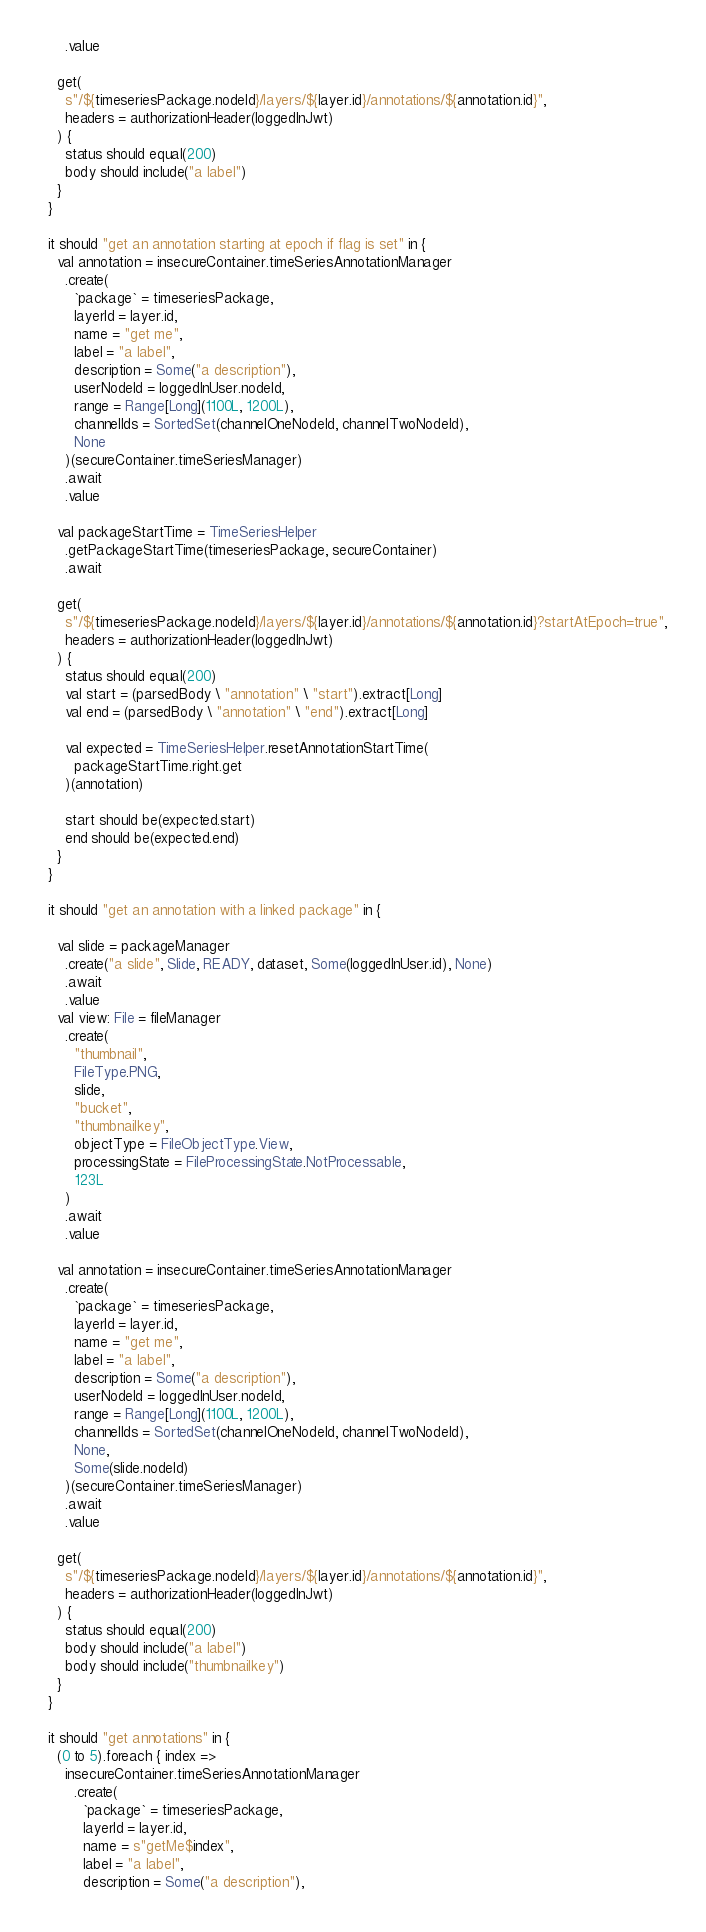Convert code to text. <code><loc_0><loc_0><loc_500><loc_500><_Scala_>      .value

    get(
      s"/${timeseriesPackage.nodeId}/layers/${layer.id}/annotations/${annotation.id}",
      headers = authorizationHeader(loggedInJwt)
    ) {
      status should equal(200)
      body should include("a label")
    }
  }

  it should "get an annotation starting at epoch if flag is set" in {
    val annotation = insecureContainer.timeSeriesAnnotationManager
      .create(
        `package` = timeseriesPackage,
        layerId = layer.id,
        name = "get me",
        label = "a label",
        description = Some("a description"),
        userNodeId = loggedInUser.nodeId,
        range = Range[Long](1100L, 1200L),
        channelIds = SortedSet(channelOneNodeId, channelTwoNodeId),
        None
      )(secureContainer.timeSeriesManager)
      .await
      .value

    val packageStartTime = TimeSeriesHelper
      .getPackageStartTime(timeseriesPackage, secureContainer)
      .await

    get(
      s"/${timeseriesPackage.nodeId}/layers/${layer.id}/annotations/${annotation.id}?startAtEpoch=true",
      headers = authorizationHeader(loggedInJwt)
    ) {
      status should equal(200)
      val start = (parsedBody \ "annotation" \ "start").extract[Long]
      val end = (parsedBody \ "annotation" \ "end").extract[Long]

      val expected = TimeSeriesHelper.resetAnnotationStartTime(
        packageStartTime.right.get
      )(annotation)

      start should be(expected.start)
      end should be(expected.end)
    }
  }

  it should "get an annotation with a linked package" in {

    val slide = packageManager
      .create("a slide", Slide, READY, dataset, Some(loggedInUser.id), None)
      .await
      .value
    val view: File = fileManager
      .create(
        "thumbnail",
        FileType.PNG,
        slide,
        "bucket",
        "thumbnailkey",
        objectType = FileObjectType.View,
        processingState = FileProcessingState.NotProcessable,
        123L
      )
      .await
      .value

    val annotation = insecureContainer.timeSeriesAnnotationManager
      .create(
        `package` = timeseriesPackage,
        layerId = layer.id,
        name = "get me",
        label = "a label",
        description = Some("a description"),
        userNodeId = loggedInUser.nodeId,
        range = Range[Long](1100L, 1200L),
        channelIds = SortedSet(channelOneNodeId, channelTwoNodeId),
        None,
        Some(slide.nodeId)
      )(secureContainer.timeSeriesManager)
      .await
      .value

    get(
      s"/${timeseriesPackage.nodeId}/layers/${layer.id}/annotations/${annotation.id}",
      headers = authorizationHeader(loggedInJwt)
    ) {
      status should equal(200)
      body should include("a label")
      body should include("thumbnailkey")
    }
  }

  it should "get annotations" in {
    (0 to 5).foreach { index =>
      insecureContainer.timeSeriesAnnotationManager
        .create(
          `package` = timeseriesPackage,
          layerId = layer.id,
          name = s"getMe$index",
          label = "a label",
          description = Some("a description"),</code> 